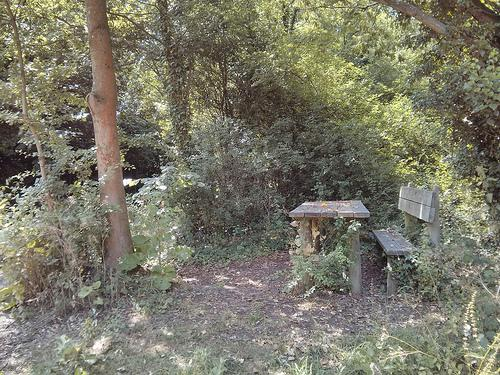Question: how many animals are in the picture?
Choices:
A. Nine.
B. Two.
C. One.
D. None.
Answer with the letter. Answer: D 